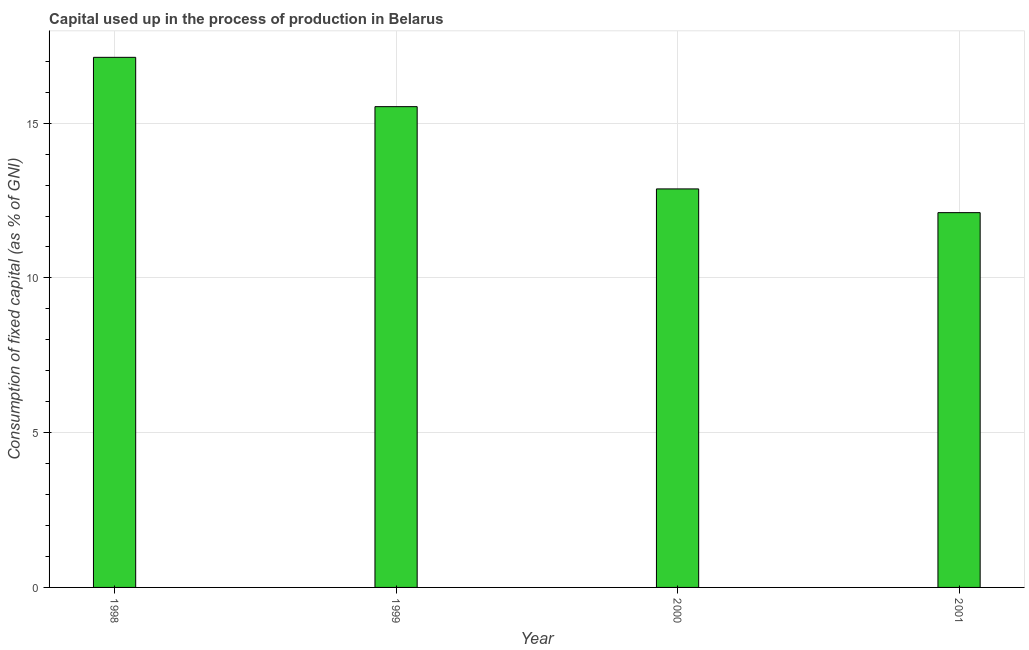Does the graph contain any zero values?
Your response must be concise. No. Does the graph contain grids?
Keep it short and to the point. Yes. What is the title of the graph?
Make the answer very short. Capital used up in the process of production in Belarus. What is the label or title of the Y-axis?
Give a very brief answer. Consumption of fixed capital (as % of GNI). What is the consumption of fixed capital in 1999?
Your answer should be very brief. 15.53. Across all years, what is the maximum consumption of fixed capital?
Keep it short and to the point. 17.13. Across all years, what is the minimum consumption of fixed capital?
Offer a very short reply. 12.11. In which year was the consumption of fixed capital maximum?
Provide a succinct answer. 1998. What is the sum of the consumption of fixed capital?
Keep it short and to the point. 57.65. What is the difference between the consumption of fixed capital in 1999 and 2000?
Ensure brevity in your answer.  2.66. What is the average consumption of fixed capital per year?
Provide a succinct answer. 14.41. What is the median consumption of fixed capital?
Give a very brief answer. 14.2. What is the ratio of the consumption of fixed capital in 2000 to that in 2001?
Ensure brevity in your answer.  1.06. Is the consumption of fixed capital in 1999 less than that in 2001?
Give a very brief answer. No. What is the difference between the highest and the second highest consumption of fixed capital?
Provide a succinct answer. 1.59. Is the sum of the consumption of fixed capital in 1999 and 2001 greater than the maximum consumption of fixed capital across all years?
Keep it short and to the point. Yes. What is the difference between the highest and the lowest consumption of fixed capital?
Your answer should be compact. 5.02. How many bars are there?
Your response must be concise. 4. Are all the bars in the graph horizontal?
Provide a succinct answer. No. How many years are there in the graph?
Provide a succinct answer. 4. What is the difference between two consecutive major ticks on the Y-axis?
Your answer should be compact. 5. Are the values on the major ticks of Y-axis written in scientific E-notation?
Make the answer very short. No. What is the Consumption of fixed capital (as % of GNI) of 1998?
Offer a terse response. 17.13. What is the Consumption of fixed capital (as % of GNI) of 1999?
Provide a short and direct response. 15.53. What is the Consumption of fixed capital (as % of GNI) of 2000?
Ensure brevity in your answer.  12.88. What is the Consumption of fixed capital (as % of GNI) of 2001?
Give a very brief answer. 12.11. What is the difference between the Consumption of fixed capital (as % of GNI) in 1998 and 1999?
Ensure brevity in your answer.  1.59. What is the difference between the Consumption of fixed capital (as % of GNI) in 1998 and 2000?
Give a very brief answer. 4.25. What is the difference between the Consumption of fixed capital (as % of GNI) in 1998 and 2001?
Offer a very short reply. 5.02. What is the difference between the Consumption of fixed capital (as % of GNI) in 1999 and 2000?
Ensure brevity in your answer.  2.66. What is the difference between the Consumption of fixed capital (as % of GNI) in 1999 and 2001?
Offer a terse response. 3.42. What is the difference between the Consumption of fixed capital (as % of GNI) in 2000 and 2001?
Give a very brief answer. 0.77. What is the ratio of the Consumption of fixed capital (as % of GNI) in 1998 to that in 1999?
Provide a short and direct response. 1.1. What is the ratio of the Consumption of fixed capital (as % of GNI) in 1998 to that in 2000?
Provide a succinct answer. 1.33. What is the ratio of the Consumption of fixed capital (as % of GNI) in 1998 to that in 2001?
Offer a very short reply. 1.41. What is the ratio of the Consumption of fixed capital (as % of GNI) in 1999 to that in 2000?
Provide a succinct answer. 1.21. What is the ratio of the Consumption of fixed capital (as % of GNI) in 1999 to that in 2001?
Give a very brief answer. 1.28. What is the ratio of the Consumption of fixed capital (as % of GNI) in 2000 to that in 2001?
Give a very brief answer. 1.06. 